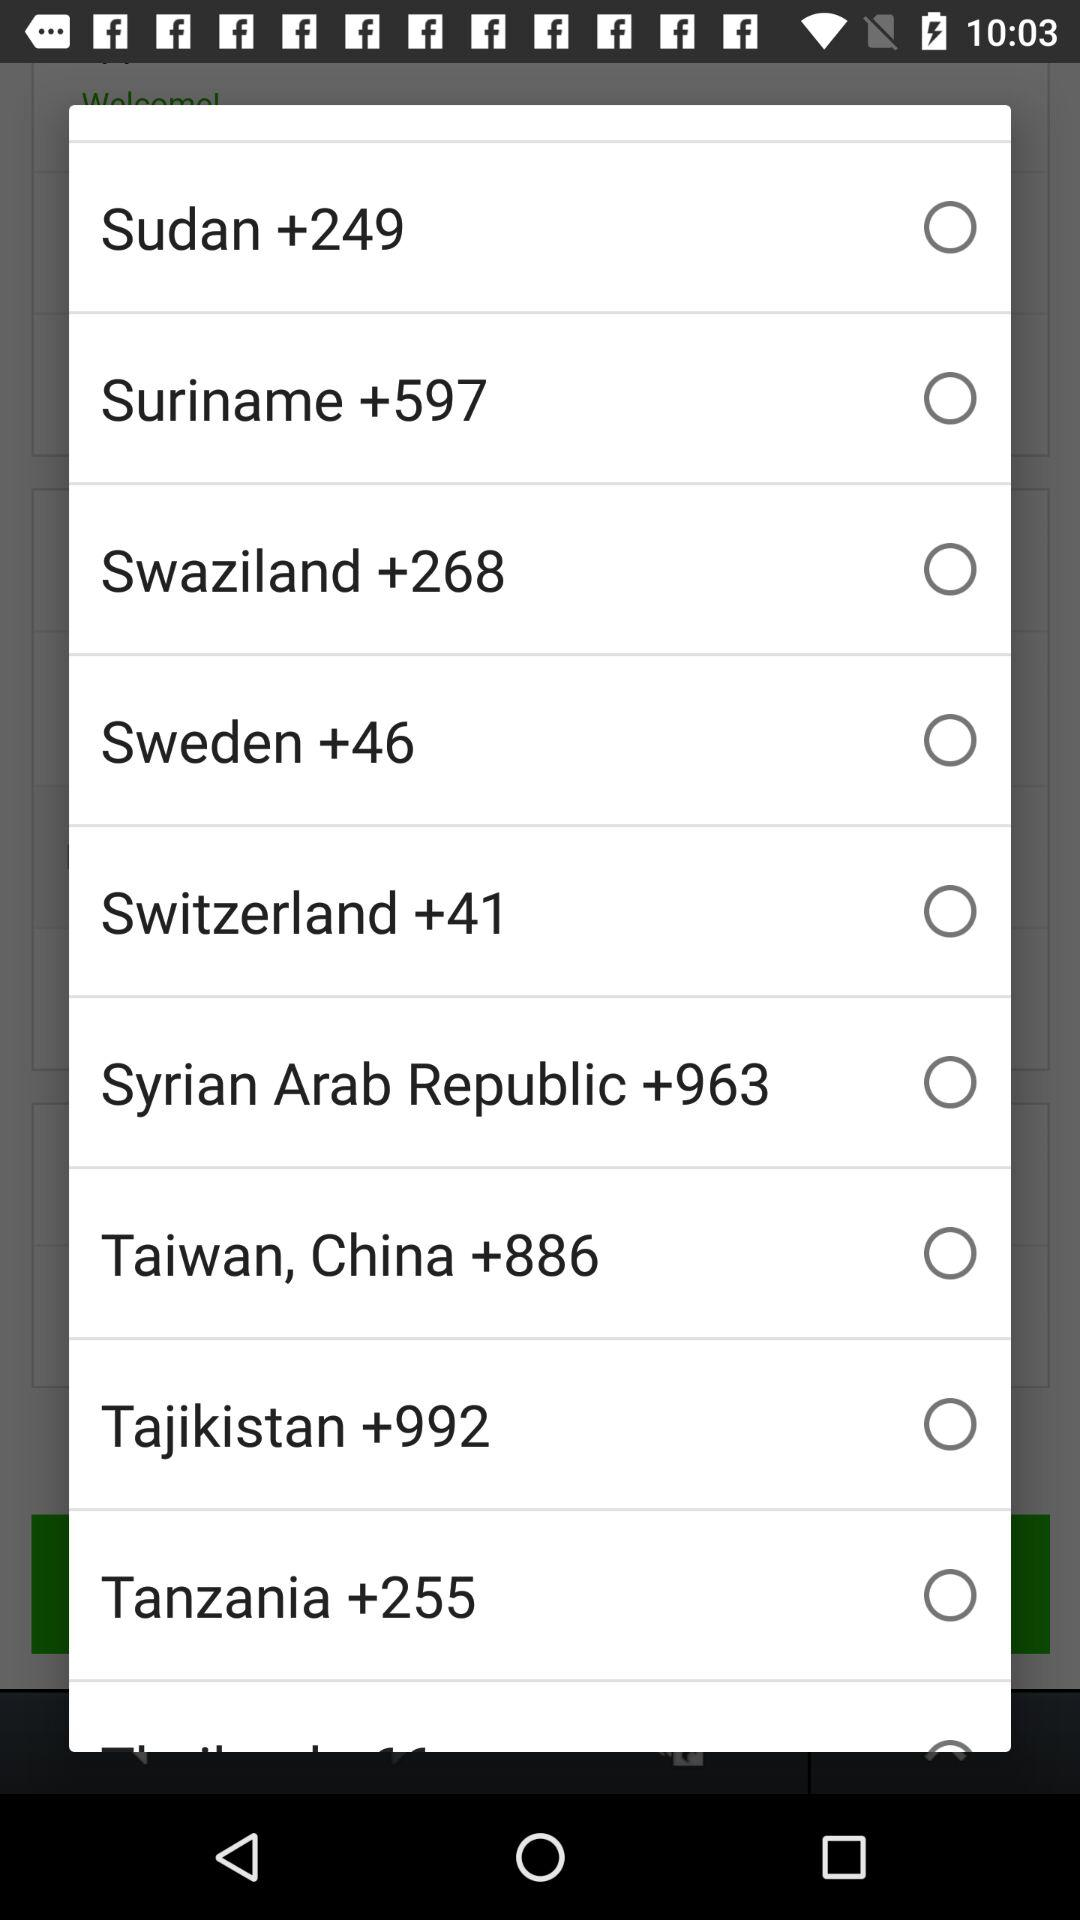What is the country code for Sweden? The country code for Sweden is +46. 